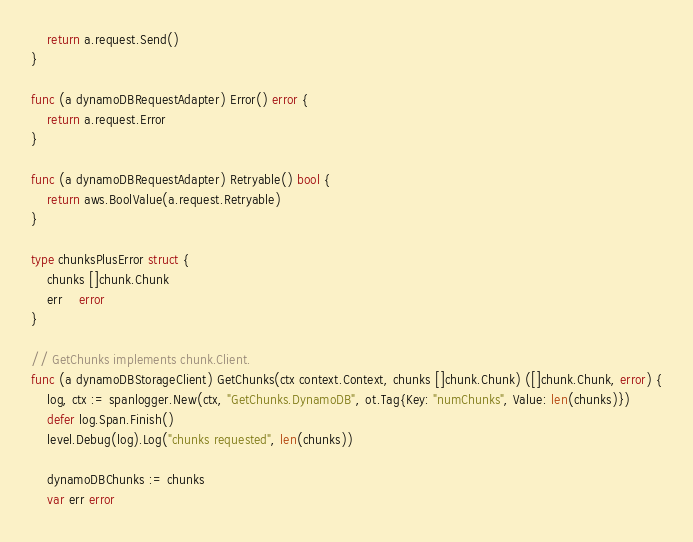Convert code to text. <code><loc_0><loc_0><loc_500><loc_500><_Go_>	return a.request.Send()
}

func (a dynamoDBRequestAdapter) Error() error {
	return a.request.Error
}

func (a dynamoDBRequestAdapter) Retryable() bool {
	return aws.BoolValue(a.request.Retryable)
}

type chunksPlusError struct {
	chunks []chunk.Chunk
	err    error
}

// GetChunks implements chunk.Client.
func (a dynamoDBStorageClient) GetChunks(ctx context.Context, chunks []chunk.Chunk) ([]chunk.Chunk, error) {
	log, ctx := spanlogger.New(ctx, "GetChunks.DynamoDB", ot.Tag{Key: "numChunks", Value: len(chunks)})
	defer log.Span.Finish()
	level.Debug(log).Log("chunks requested", len(chunks))

	dynamoDBChunks := chunks
	var err error
</code> 